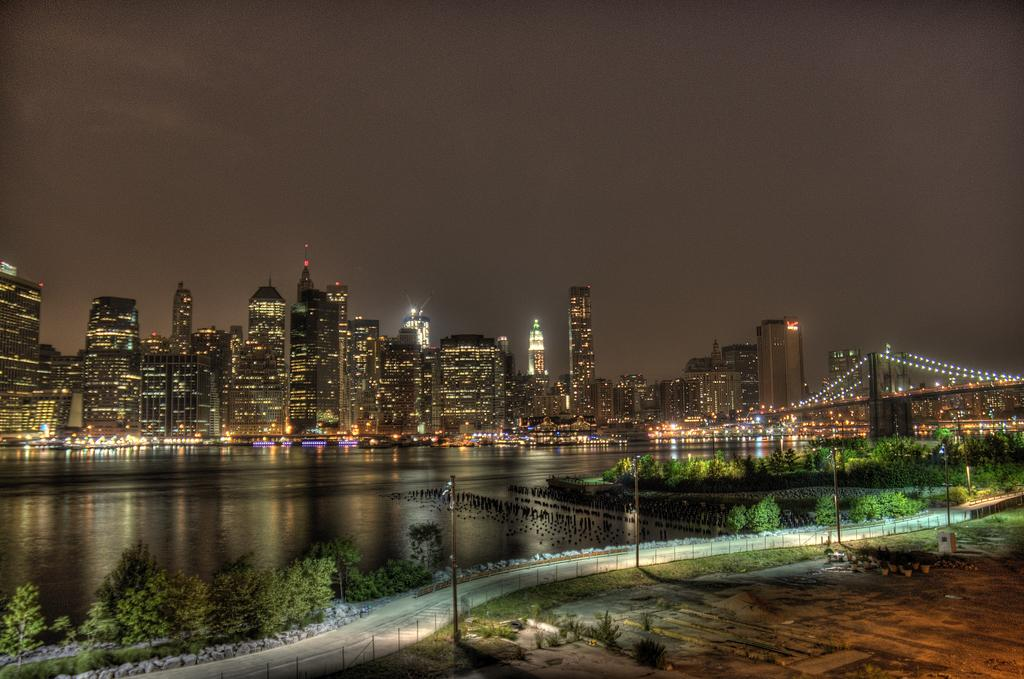What is one of the main elements in the image? There is water in the image. What type of vegetation can be seen in the image? There are plants in the image. What kind of surface is present for walking or traversing? There is a path in the image. What type of ground cover is visible in the image? There is grass in the image. What is the base surface on which everything else is situated? There is ground in the image. What structure is present for crossing the water? There is a bridge in the image. What provides illumination in the image? There are lights in the image. What type of vertical structures are present in the image? There are rods in the image. What type of man-made structures can be seen in the image? There are buildings in the image. What is visible in the background of the image? The sky is visible in the background of the image. What type of powder is visible in the image? There is no powder visible in the image. What type of clouds can be seen in the image? The sky is visible in the background of the image, but there are no clouds mentioned in the facts. What type of hospital is present in the image? There is no hospital present in the image. 